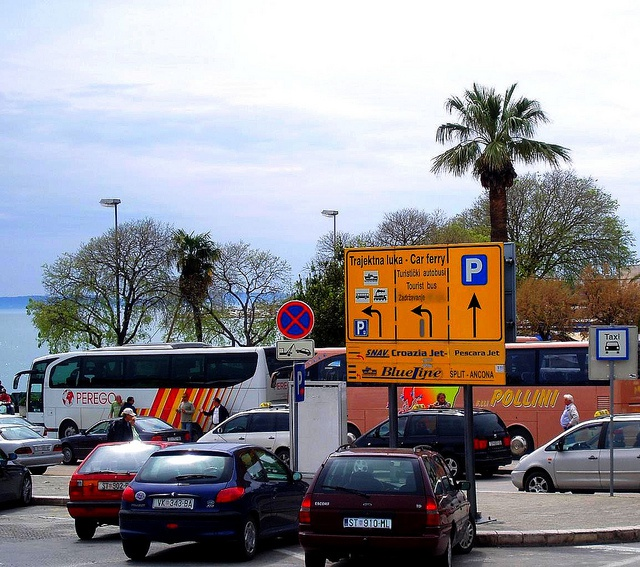Describe the objects in this image and their specific colors. I can see car in lavender, black, gray, navy, and blue tones, car in lavender, black, navy, and gray tones, bus in lavender, black, darkgray, and gray tones, bus in lavender, black, brown, and maroon tones, and car in lavender, gray, black, darkgray, and navy tones in this image. 